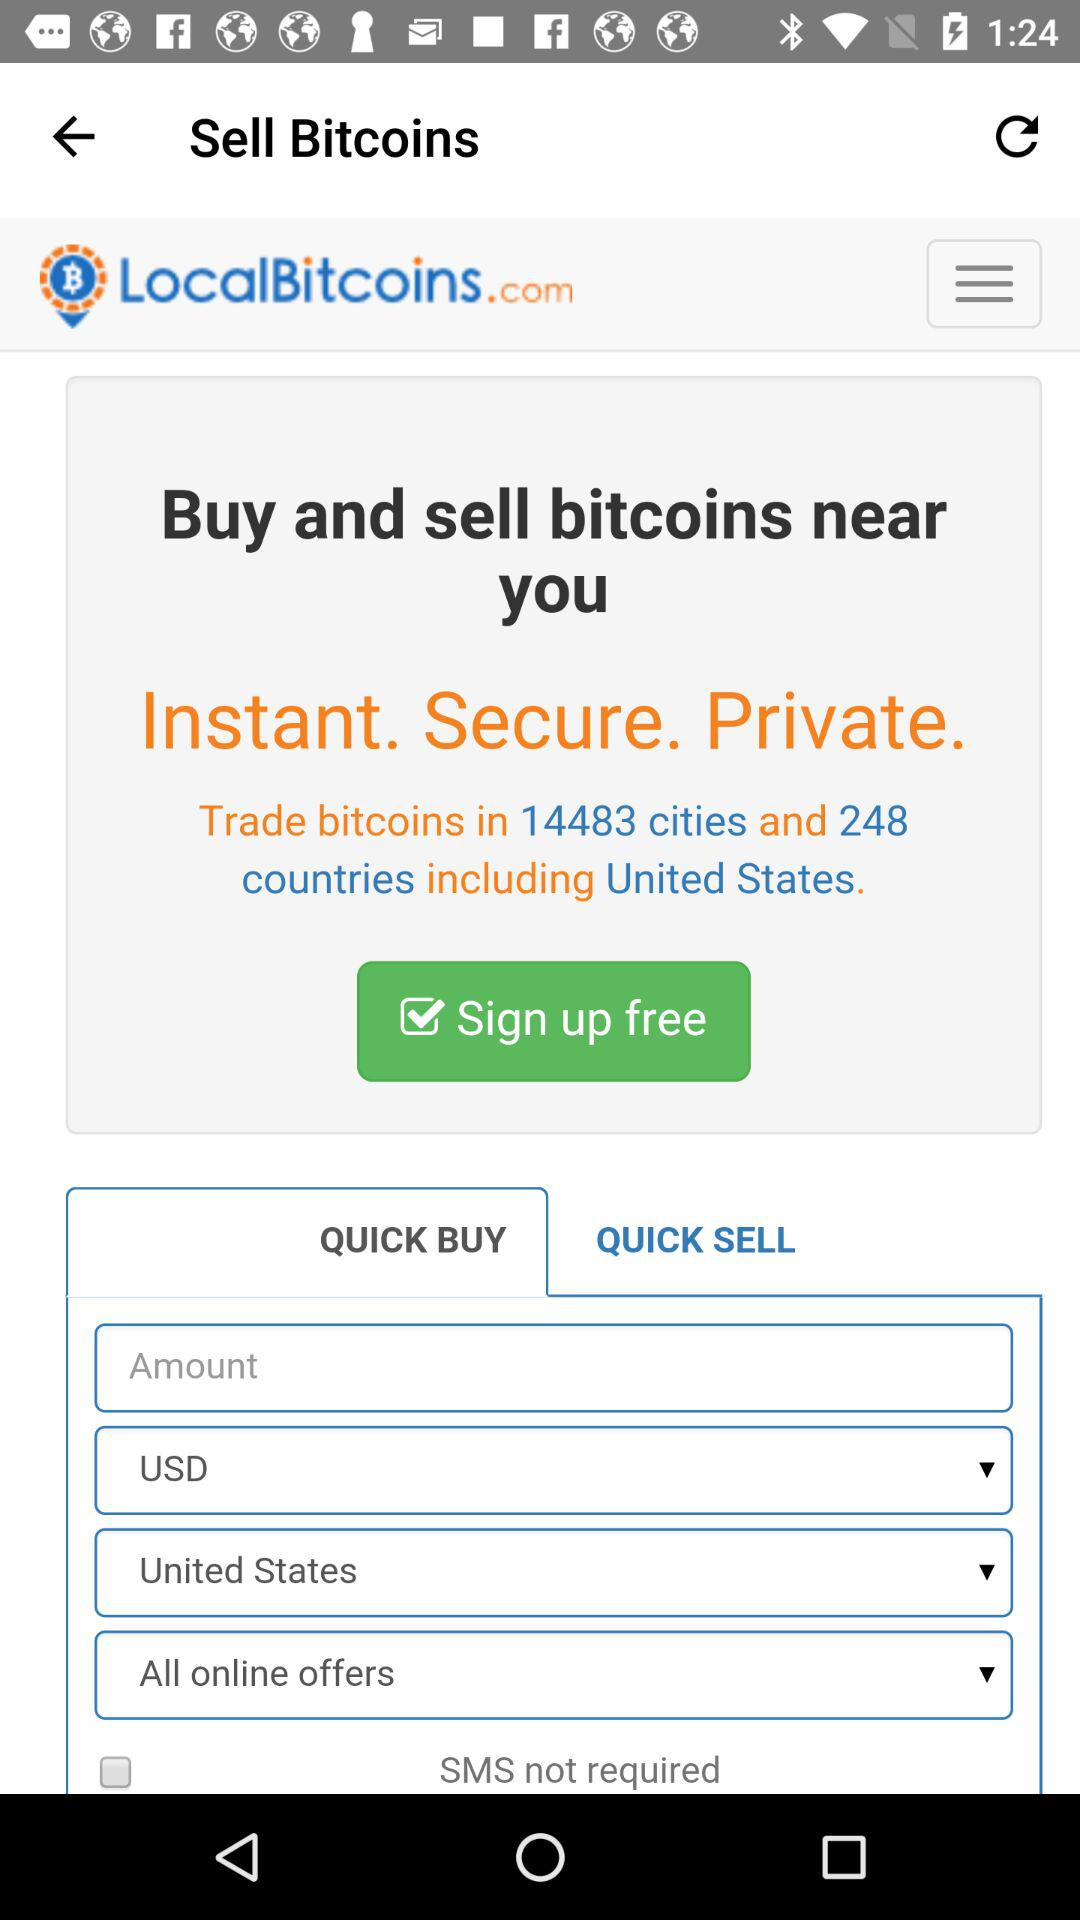Is signing up free or not? Signing up is free. 